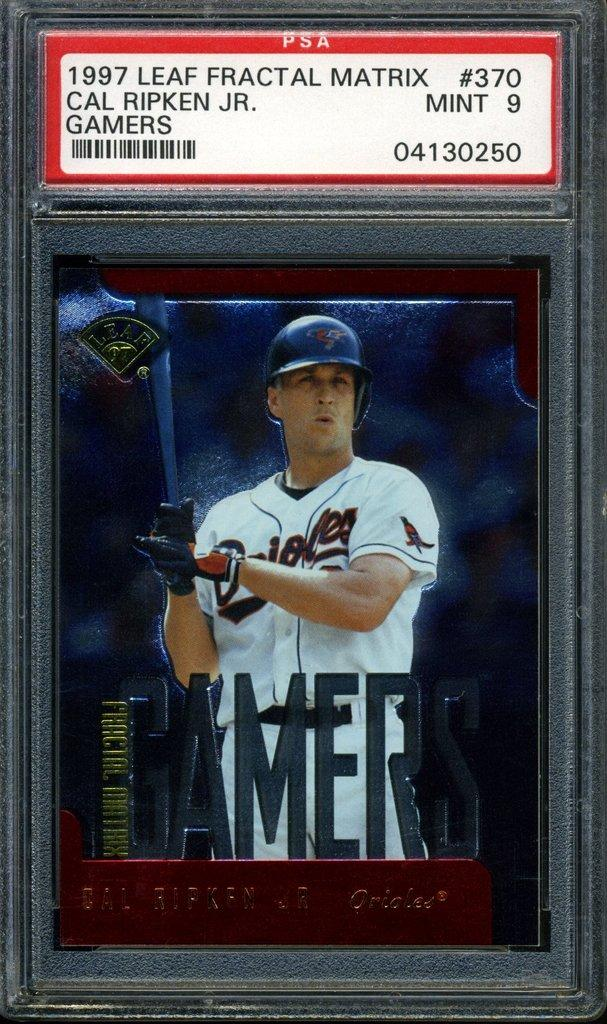<image>
Summarize the visual content of the image. A black case shows a baseball card for Cal Ripken Jr. 